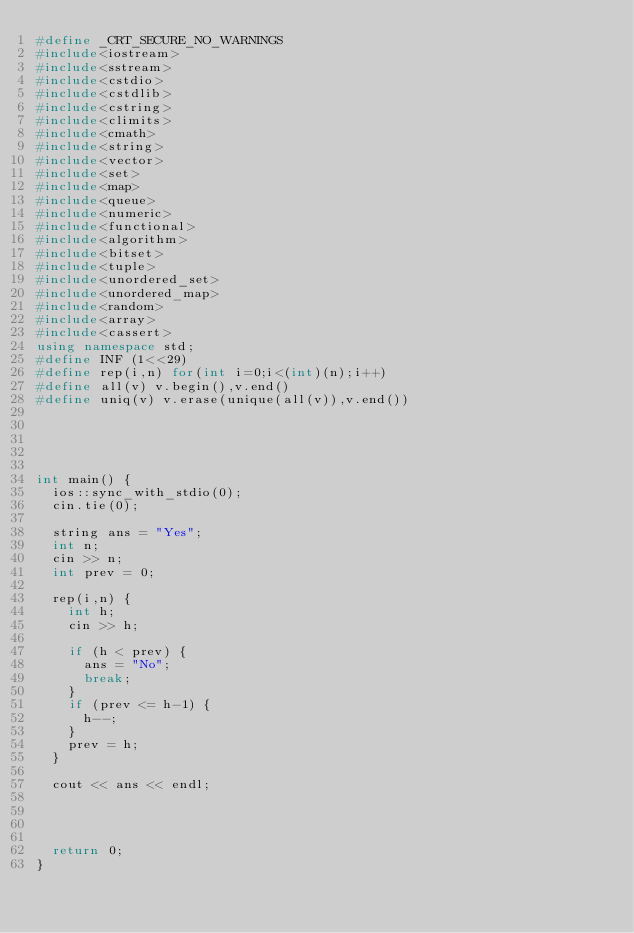Convert code to text. <code><loc_0><loc_0><loc_500><loc_500><_C++_>#define _CRT_SECURE_NO_WARNINGS
#include<iostream>
#include<sstream>
#include<cstdio>
#include<cstdlib>
#include<cstring>
#include<climits>
#include<cmath>
#include<string>
#include<vector>
#include<set>
#include<map>
#include<queue>
#include<numeric>
#include<functional>
#include<algorithm>
#include<bitset>
#include<tuple>
#include<unordered_set>
#include<unordered_map>
#include<random>
#include<array>
#include<cassert>
using namespace std;
#define INF (1<<29)
#define rep(i,n) for(int i=0;i<(int)(n);i++)
#define all(v) v.begin(),v.end()
#define uniq(v) v.erase(unique(all(v)),v.end())





int main() {
	ios::sync_with_stdio(0);
	cin.tie(0);

	string ans = "Yes";
	int n;
	cin >> n;
	int prev = 0;

	rep(i,n) {
		int h;
		cin >> h;

		if (h < prev) {
			ans = "No";
			break;
		}
		if (prev <= h-1) {
			h--;
		}
		prev = h;
	}

	cout << ans << endl;




	return 0;
}</code> 